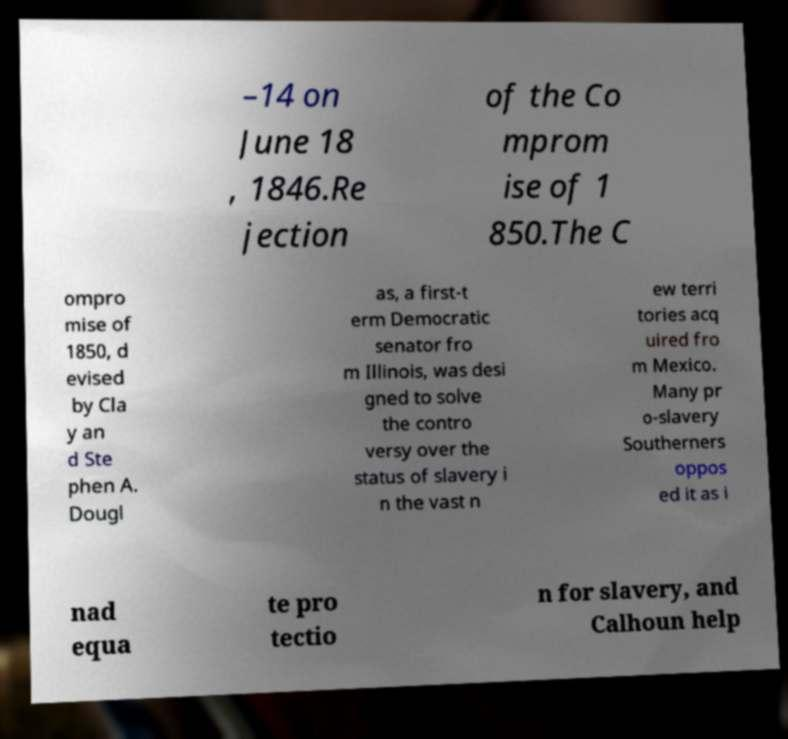There's text embedded in this image that I need extracted. Can you transcribe it verbatim? –14 on June 18 , 1846.Re jection of the Co mprom ise of 1 850.The C ompro mise of 1850, d evised by Cla y an d Ste phen A. Dougl as, a first-t erm Democratic senator fro m Illinois, was desi gned to solve the contro versy over the status of slavery i n the vast n ew terri tories acq uired fro m Mexico. Many pr o-slavery Southerners oppos ed it as i nad equa te pro tectio n for slavery, and Calhoun help 